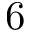<formula> <loc_0><loc_0><loc_500><loc_500>6</formula> 